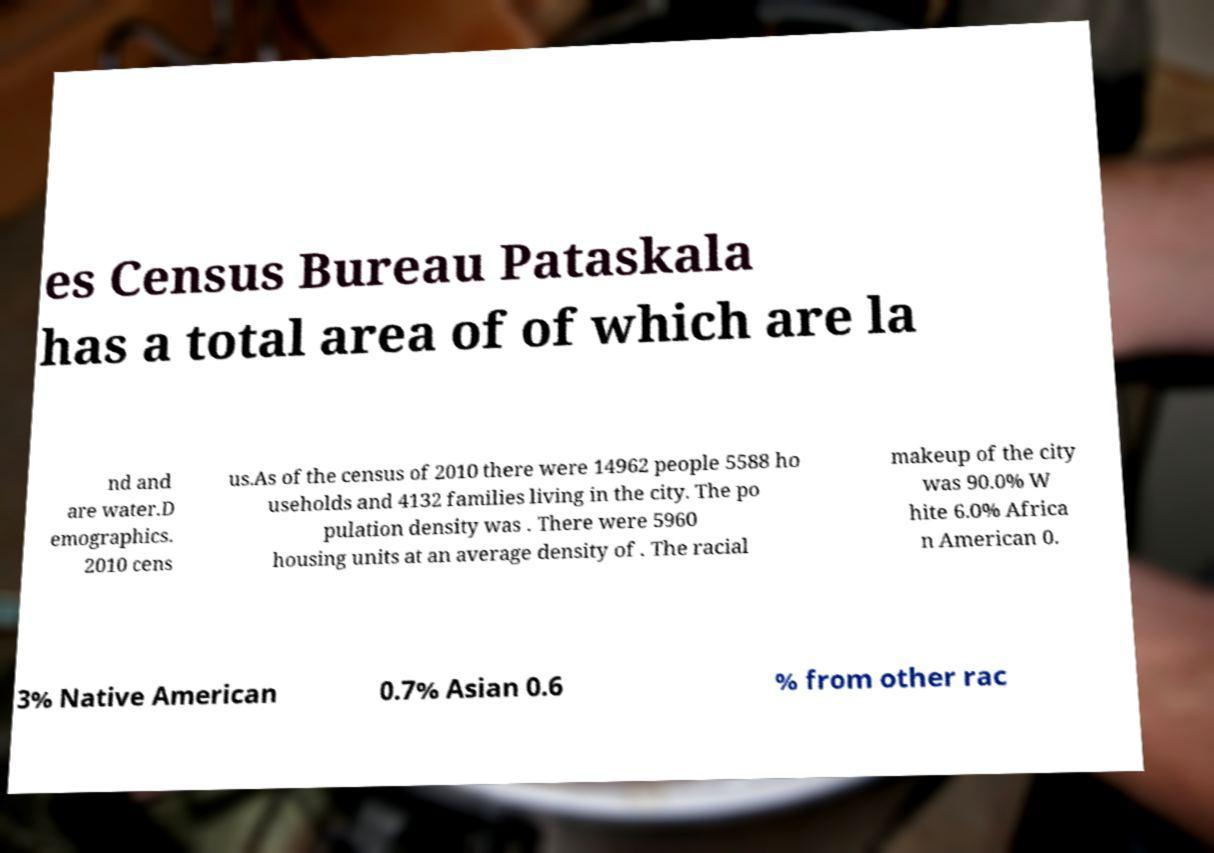What messages or text are displayed in this image? I need them in a readable, typed format. es Census Bureau Pataskala has a total area of of which are la nd and are water.D emographics. 2010 cens us.As of the census of 2010 there were 14962 people 5588 ho useholds and 4132 families living in the city. The po pulation density was . There were 5960 housing units at an average density of . The racial makeup of the city was 90.0% W hite 6.0% Africa n American 0. 3% Native American 0.7% Asian 0.6 % from other rac 